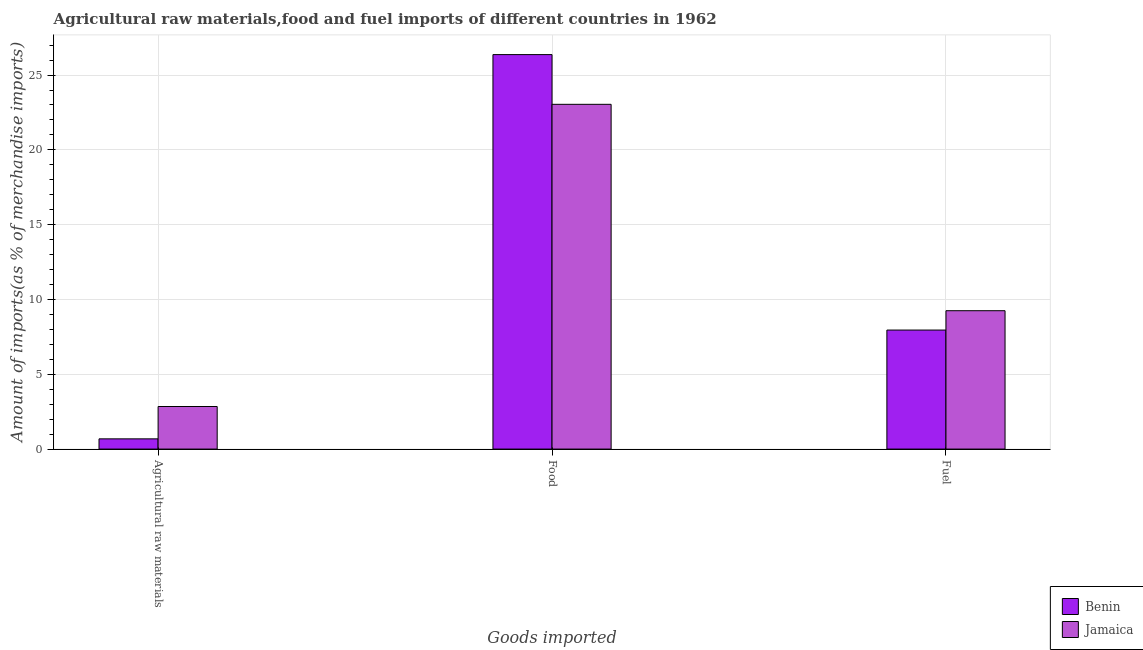How many different coloured bars are there?
Your answer should be compact. 2. How many groups of bars are there?
Your answer should be compact. 3. Are the number of bars on each tick of the X-axis equal?
Offer a very short reply. Yes. How many bars are there on the 2nd tick from the right?
Your response must be concise. 2. What is the label of the 3rd group of bars from the left?
Give a very brief answer. Fuel. What is the percentage of food imports in Jamaica?
Ensure brevity in your answer.  23.04. Across all countries, what is the maximum percentage of food imports?
Provide a succinct answer. 26.37. Across all countries, what is the minimum percentage of raw materials imports?
Offer a terse response. 0.68. In which country was the percentage of fuel imports maximum?
Provide a succinct answer. Jamaica. In which country was the percentage of food imports minimum?
Make the answer very short. Jamaica. What is the total percentage of fuel imports in the graph?
Your answer should be very brief. 17.2. What is the difference between the percentage of raw materials imports in Jamaica and that in Benin?
Give a very brief answer. 2.16. What is the difference between the percentage of fuel imports in Benin and the percentage of food imports in Jamaica?
Ensure brevity in your answer.  -15.09. What is the average percentage of food imports per country?
Make the answer very short. 24.7. What is the difference between the percentage of fuel imports and percentage of food imports in Benin?
Your answer should be compact. -18.41. What is the ratio of the percentage of fuel imports in Benin to that in Jamaica?
Your answer should be very brief. 0.86. What is the difference between the highest and the second highest percentage of raw materials imports?
Make the answer very short. 2.16. What is the difference between the highest and the lowest percentage of fuel imports?
Make the answer very short. 1.29. In how many countries, is the percentage of fuel imports greater than the average percentage of fuel imports taken over all countries?
Provide a succinct answer. 1. Is the sum of the percentage of raw materials imports in Benin and Jamaica greater than the maximum percentage of fuel imports across all countries?
Offer a very short reply. No. What does the 1st bar from the left in Food represents?
Your answer should be very brief. Benin. What does the 2nd bar from the right in Agricultural raw materials represents?
Keep it short and to the point. Benin. Is it the case that in every country, the sum of the percentage of raw materials imports and percentage of food imports is greater than the percentage of fuel imports?
Provide a short and direct response. Yes. How many bars are there?
Provide a short and direct response. 6. What is the difference between two consecutive major ticks on the Y-axis?
Offer a terse response. 5. Does the graph contain grids?
Offer a very short reply. Yes. What is the title of the graph?
Give a very brief answer. Agricultural raw materials,food and fuel imports of different countries in 1962. What is the label or title of the X-axis?
Provide a short and direct response. Goods imported. What is the label or title of the Y-axis?
Offer a terse response. Amount of imports(as % of merchandise imports). What is the Amount of imports(as % of merchandise imports) in Benin in Agricultural raw materials?
Your answer should be compact. 0.68. What is the Amount of imports(as % of merchandise imports) in Jamaica in Agricultural raw materials?
Offer a very short reply. 2.84. What is the Amount of imports(as % of merchandise imports) in Benin in Food?
Provide a short and direct response. 26.37. What is the Amount of imports(as % of merchandise imports) of Jamaica in Food?
Your response must be concise. 23.04. What is the Amount of imports(as % of merchandise imports) of Benin in Fuel?
Your answer should be very brief. 7.96. What is the Amount of imports(as % of merchandise imports) in Jamaica in Fuel?
Your answer should be compact. 9.25. Across all Goods imported, what is the maximum Amount of imports(as % of merchandise imports) of Benin?
Give a very brief answer. 26.37. Across all Goods imported, what is the maximum Amount of imports(as % of merchandise imports) of Jamaica?
Offer a terse response. 23.04. Across all Goods imported, what is the minimum Amount of imports(as % of merchandise imports) in Benin?
Offer a very short reply. 0.68. Across all Goods imported, what is the minimum Amount of imports(as % of merchandise imports) of Jamaica?
Keep it short and to the point. 2.84. What is the total Amount of imports(as % of merchandise imports) of Benin in the graph?
Give a very brief answer. 35.01. What is the total Amount of imports(as % of merchandise imports) of Jamaica in the graph?
Provide a succinct answer. 35.14. What is the difference between the Amount of imports(as % of merchandise imports) in Benin in Agricultural raw materials and that in Food?
Keep it short and to the point. -25.68. What is the difference between the Amount of imports(as % of merchandise imports) in Jamaica in Agricultural raw materials and that in Food?
Ensure brevity in your answer.  -20.2. What is the difference between the Amount of imports(as % of merchandise imports) of Benin in Agricultural raw materials and that in Fuel?
Offer a terse response. -7.27. What is the difference between the Amount of imports(as % of merchandise imports) of Jamaica in Agricultural raw materials and that in Fuel?
Make the answer very short. -6.4. What is the difference between the Amount of imports(as % of merchandise imports) in Benin in Food and that in Fuel?
Give a very brief answer. 18.41. What is the difference between the Amount of imports(as % of merchandise imports) of Jamaica in Food and that in Fuel?
Your answer should be compact. 13.79. What is the difference between the Amount of imports(as % of merchandise imports) of Benin in Agricultural raw materials and the Amount of imports(as % of merchandise imports) of Jamaica in Food?
Provide a succinct answer. -22.36. What is the difference between the Amount of imports(as % of merchandise imports) of Benin in Agricultural raw materials and the Amount of imports(as % of merchandise imports) of Jamaica in Fuel?
Your answer should be very brief. -8.56. What is the difference between the Amount of imports(as % of merchandise imports) in Benin in Food and the Amount of imports(as % of merchandise imports) in Jamaica in Fuel?
Your answer should be compact. 17.12. What is the average Amount of imports(as % of merchandise imports) in Benin per Goods imported?
Ensure brevity in your answer.  11.67. What is the average Amount of imports(as % of merchandise imports) of Jamaica per Goods imported?
Keep it short and to the point. 11.71. What is the difference between the Amount of imports(as % of merchandise imports) in Benin and Amount of imports(as % of merchandise imports) in Jamaica in Agricultural raw materials?
Offer a very short reply. -2.16. What is the difference between the Amount of imports(as % of merchandise imports) of Benin and Amount of imports(as % of merchandise imports) of Jamaica in Food?
Make the answer very short. 3.32. What is the difference between the Amount of imports(as % of merchandise imports) of Benin and Amount of imports(as % of merchandise imports) of Jamaica in Fuel?
Provide a succinct answer. -1.29. What is the ratio of the Amount of imports(as % of merchandise imports) of Benin in Agricultural raw materials to that in Food?
Give a very brief answer. 0.03. What is the ratio of the Amount of imports(as % of merchandise imports) in Jamaica in Agricultural raw materials to that in Food?
Give a very brief answer. 0.12. What is the ratio of the Amount of imports(as % of merchandise imports) of Benin in Agricultural raw materials to that in Fuel?
Provide a succinct answer. 0.09. What is the ratio of the Amount of imports(as % of merchandise imports) of Jamaica in Agricultural raw materials to that in Fuel?
Provide a short and direct response. 0.31. What is the ratio of the Amount of imports(as % of merchandise imports) in Benin in Food to that in Fuel?
Keep it short and to the point. 3.31. What is the ratio of the Amount of imports(as % of merchandise imports) of Jamaica in Food to that in Fuel?
Your response must be concise. 2.49. What is the difference between the highest and the second highest Amount of imports(as % of merchandise imports) in Benin?
Give a very brief answer. 18.41. What is the difference between the highest and the second highest Amount of imports(as % of merchandise imports) of Jamaica?
Offer a terse response. 13.79. What is the difference between the highest and the lowest Amount of imports(as % of merchandise imports) in Benin?
Provide a short and direct response. 25.68. What is the difference between the highest and the lowest Amount of imports(as % of merchandise imports) of Jamaica?
Your answer should be very brief. 20.2. 